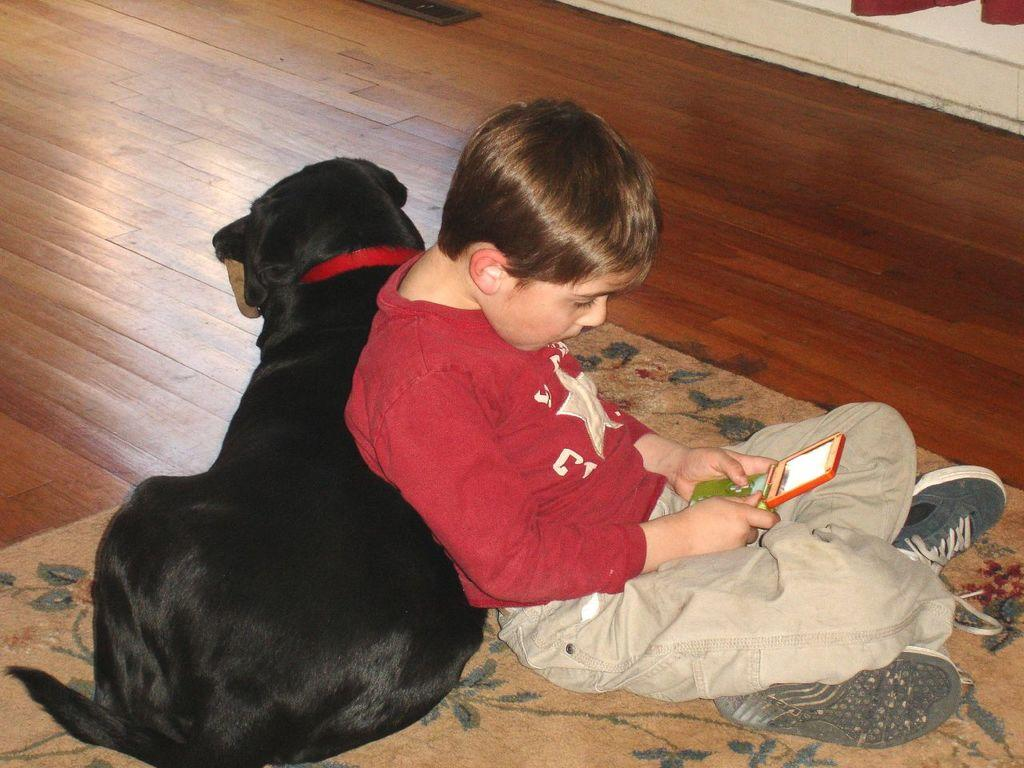Who is the main subject in the image? There is a boy in the image. What is the boy wearing? The boy is wearing a red t-shirt. What is the boy holding in his hand? The boy is holding a phone in his hand. What other living creature is present in the image? There is a dog in the image. Where is the dog sitting? The dog is sitting on a carpet. What object can be seen on the floor? There is a strap on the floor. Can you tell me how much the receipt costs in the image? There is no receipt present in the image. How many dimes can be seen on the floor in the image? There are no dimes present in the image. 